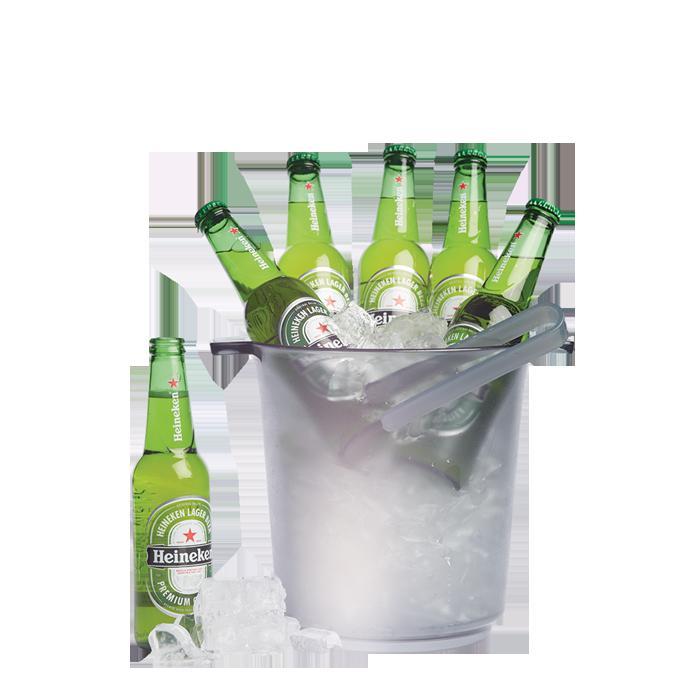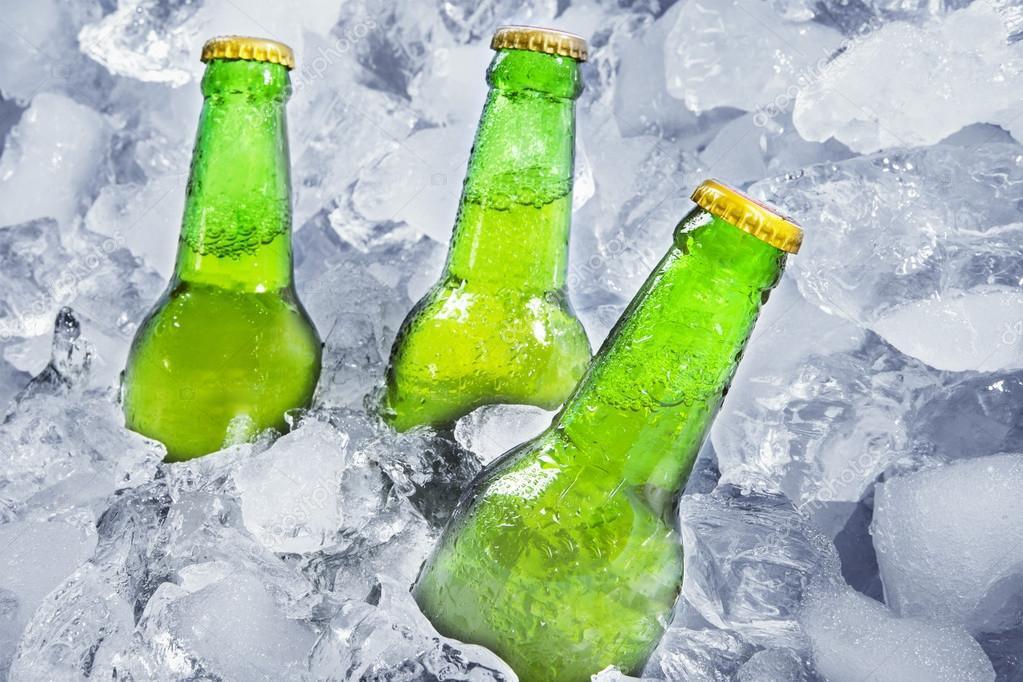The first image is the image on the left, the second image is the image on the right. Analyze the images presented: Is the assertion "One image shows several bottles sticking out of a bucket." valid? Answer yes or no. Yes. The first image is the image on the left, the second image is the image on the right. For the images shown, is this caption "there are exactly three bottles in the image on the right." true? Answer yes or no. Yes. 